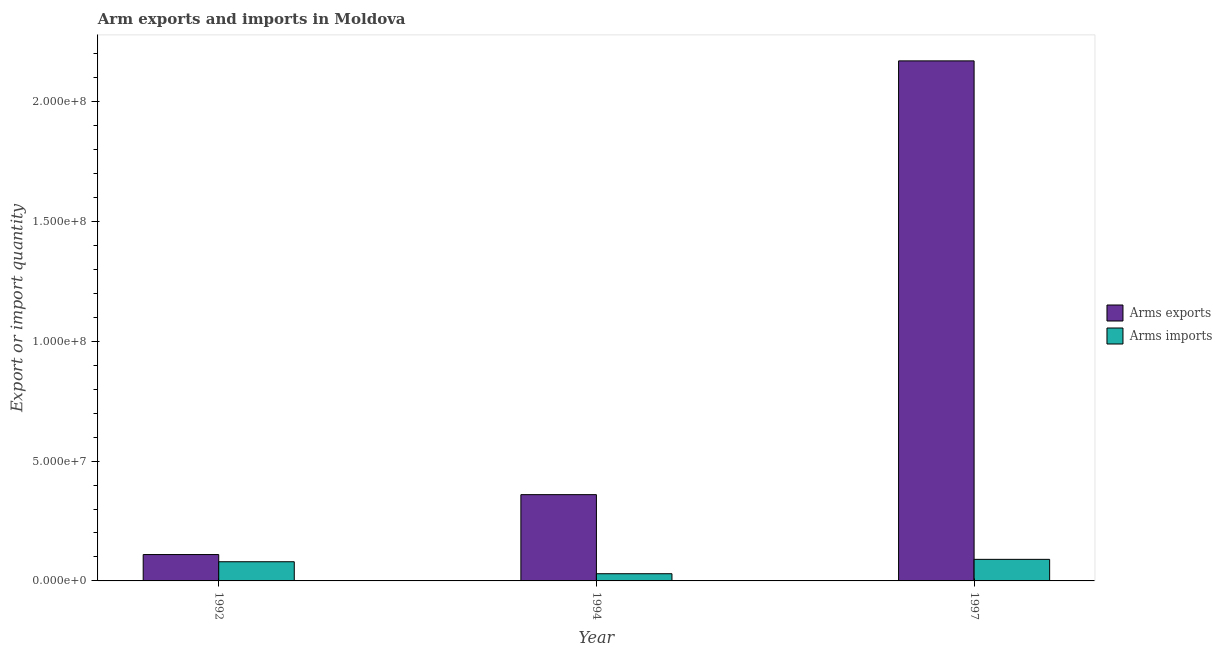How many different coloured bars are there?
Provide a succinct answer. 2. Are the number of bars per tick equal to the number of legend labels?
Offer a very short reply. Yes. What is the label of the 1st group of bars from the left?
Give a very brief answer. 1992. What is the arms exports in 1992?
Ensure brevity in your answer.  1.10e+07. Across all years, what is the maximum arms imports?
Ensure brevity in your answer.  9.00e+06. Across all years, what is the minimum arms exports?
Provide a short and direct response. 1.10e+07. What is the total arms imports in the graph?
Keep it short and to the point. 2.00e+07. What is the difference between the arms exports in 1992 and that in 1994?
Your answer should be compact. -2.50e+07. What is the difference between the arms imports in 1992 and the arms exports in 1994?
Offer a terse response. 5.00e+06. What is the average arms exports per year?
Ensure brevity in your answer.  8.80e+07. What is the ratio of the arms imports in 1994 to that in 1997?
Offer a terse response. 0.33. What is the difference between the highest and the second highest arms exports?
Make the answer very short. 1.81e+08. What is the difference between the highest and the lowest arms imports?
Provide a short and direct response. 6.00e+06. What does the 1st bar from the left in 1992 represents?
Give a very brief answer. Arms exports. What does the 1st bar from the right in 1994 represents?
Provide a succinct answer. Arms imports. How many bars are there?
Ensure brevity in your answer.  6. Are all the bars in the graph horizontal?
Keep it short and to the point. No. What is the difference between two consecutive major ticks on the Y-axis?
Your answer should be very brief. 5.00e+07. Does the graph contain any zero values?
Your answer should be very brief. No. How are the legend labels stacked?
Give a very brief answer. Vertical. What is the title of the graph?
Offer a very short reply. Arm exports and imports in Moldova. Does "Investment in Telecom" appear as one of the legend labels in the graph?
Provide a short and direct response. No. What is the label or title of the X-axis?
Your answer should be very brief. Year. What is the label or title of the Y-axis?
Provide a short and direct response. Export or import quantity. What is the Export or import quantity of Arms exports in 1992?
Keep it short and to the point. 1.10e+07. What is the Export or import quantity of Arms imports in 1992?
Keep it short and to the point. 8.00e+06. What is the Export or import quantity in Arms exports in 1994?
Keep it short and to the point. 3.60e+07. What is the Export or import quantity of Arms exports in 1997?
Offer a terse response. 2.17e+08. What is the Export or import quantity of Arms imports in 1997?
Your answer should be compact. 9.00e+06. Across all years, what is the maximum Export or import quantity of Arms exports?
Ensure brevity in your answer.  2.17e+08. Across all years, what is the maximum Export or import quantity in Arms imports?
Give a very brief answer. 9.00e+06. Across all years, what is the minimum Export or import quantity of Arms exports?
Keep it short and to the point. 1.10e+07. Across all years, what is the minimum Export or import quantity in Arms imports?
Provide a succinct answer. 3.00e+06. What is the total Export or import quantity of Arms exports in the graph?
Your answer should be very brief. 2.64e+08. What is the difference between the Export or import quantity of Arms exports in 1992 and that in 1994?
Offer a terse response. -2.50e+07. What is the difference between the Export or import quantity of Arms exports in 1992 and that in 1997?
Provide a short and direct response. -2.06e+08. What is the difference between the Export or import quantity of Arms exports in 1994 and that in 1997?
Keep it short and to the point. -1.81e+08. What is the difference between the Export or import quantity in Arms imports in 1994 and that in 1997?
Provide a short and direct response. -6.00e+06. What is the difference between the Export or import quantity of Arms exports in 1992 and the Export or import quantity of Arms imports in 1994?
Your response must be concise. 8.00e+06. What is the difference between the Export or import quantity in Arms exports in 1994 and the Export or import quantity in Arms imports in 1997?
Ensure brevity in your answer.  2.70e+07. What is the average Export or import quantity in Arms exports per year?
Make the answer very short. 8.80e+07. What is the average Export or import quantity of Arms imports per year?
Provide a short and direct response. 6.67e+06. In the year 1994, what is the difference between the Export or import quantity of Arms exports and Export or import quantity of Arms imports?
Offer a very short reply. 3.30e+07. In the year 1997, what is the difference between the Export or import quantity of Arms exports and Export or import quantity of Arms imports?
Provide a short and direct response. 2.08e+08. What is the ratio of the Export or import quantity in Arms exports in 1992 to that in 1994?
Offer a terse response. 0.31. What is the ratio of the Export or import quantity of Arms imports in 1992 to that in 1994?
Keep it short and to the point. 2.67. What is the ratio of the Export or import quantity in Arms exports in 1992 to that in 1997?
Make the answer very short. 0.05. What is the ratio of the Export or import quantity of Arms imports in 1992 to that in 1997?
Make the answer very short. 0.89. What is the ratio of the Export or import quantity in Arms exports in 1994 to that in 1997?
Make the answer very short. 0.17. What is the difference between the highest and the second highest Export or import quantity in Arms exports?
Keep it short and to the point. 1.81e+08. What is the difference between the highest and the second highest Export or import quantity of Arms imports?
Offer a very short reply. 1.00e+06. What is the difference between the highest and the lowest Export or import quantity in Arms exports?
Offer a terse response. 2.06e+08. 